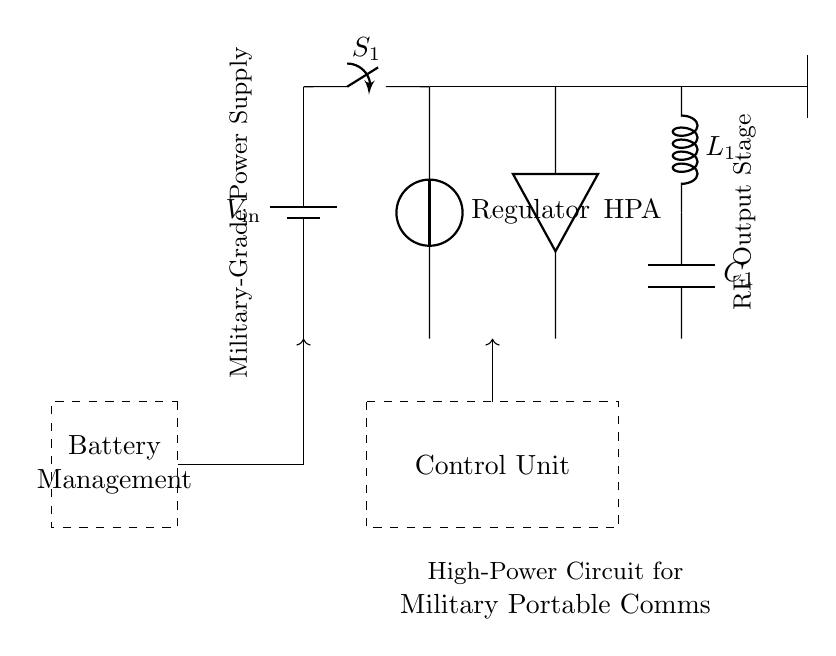What is the input voltage of the power source? The input voltage is labeled as V_in, which indicates the voltage supplied to the circuit.
Answer: V_in What component is responsible for amplifying the signal? The high-power amplifier (HPA) is shown in the circuit diagram as the device that increases the power of the signal.
Answer: HPA What type of components are used in the antenna matching network? The components in the antenna matching network are a inductor (L_1) and a capacitor (C_1), which are used for impedance matching.
Answer: Inductor and capacitor How does the power source connect to the main switch? The power source connects directly to the main switch (S_1) through wiring shown in the diagram, making it the first component in the power path.
Answer: Directly What is the function of the control unit in this circuit? The control unit is encapsulated in a dashed rectangle; its role is to manage the operations of the circuit components and ensure proper functioning during communication.
Answer: Management What is the purpose of the battery management component? The battery management system is indicated by another dashed rectangle; it ensures efficient charging and discharging of the battery to maintain power supply stability.
Answer: Power stabilization 